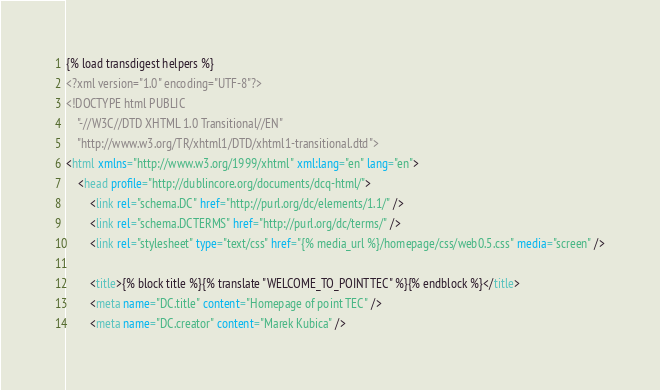Convert code to text. <code><loc_0><loc_0><loc_500><loc_500><_HTML_>{% load transdigest helpers %}
<?xml version="1.0" encoding="UTF-8"?>
<!DOCTYPE html PUBLIC
    "-//W3C//DTD XHTML 1.0 Transitional//EN"
    "http://www.w3.org/TR/xhtml1/DTD/xhtml1-transitional.dtd">
<html xmlns="http://www.w3.org/1999/xhtml" xml:lang="en" lang="en">
    <head profile="http://dublincore.org/documents/dcq-html/">
        <link rel="schema.DC" href="http://purl.org/dc/elements/1.1/" />
        <link rel="schema.DCTERMS" href="http://purl.org/dc/terms/" />
        <link rel="stylesheet" type="text/css" href="{% media_url %}/homepage/css/web0.5.css" media="screen" />

        <title>{% block title %}{% translate "WELCOME_TO_POINTTEC" %}{% endblock %}</title>
        <meta name="DC.title" content="Homepage of point TEC" />
        <meta name="DC.creator" content="Marek Kubica" /></code> 